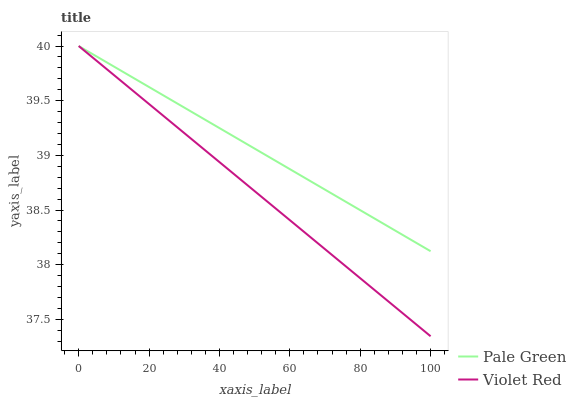Does Violet Red have the minimum area under the curve?
Answer yes or no. Yes. Does Pale Green have the maximum area under the curve?
Answer yes or no. Yes. Does Pale Green have the minimum area under the curve?
Answer yes or no. No. Is Pale Green the smoothest?
Answer yes or no. Yes. Is Violet Red the roughest?
Answer yes or no. Yes. Is Pale Green the roughest?
Answer yes or no. No. Does Violet Red have the lowest value?
Answer yes or no. Yes. Does Pale Green have the lowest value?
Answer yes or no. No. Does Pale Green have the highest value?
Answer yes or no. Yes. Does Pale Green intersect Violet Red?
Answer yes or no. Yes. Is Pale Green less than Violet Red?
Answer yes or no. No. Is Pale Green greater than Violet Red?
Answer yes or no. No. 